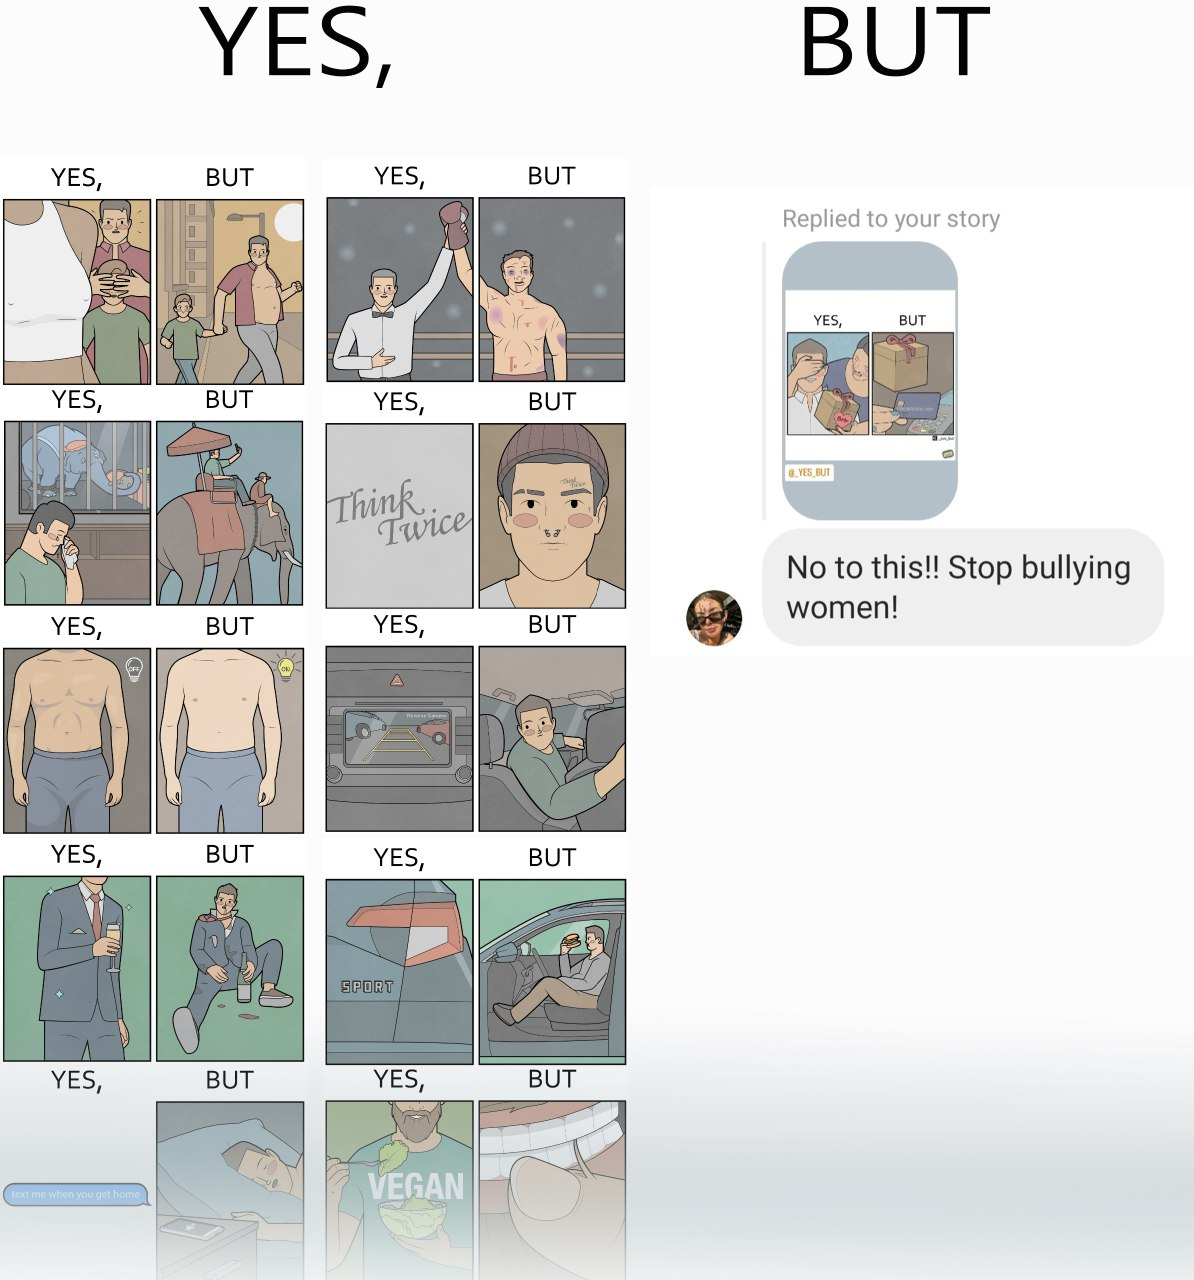What is shown in the left half versus the right half of this image? In the left part of the image: many images, kind of meme, kept in a gallery In the right part of the image: a screenshot of some person replying to other's story raising voice over woman bullying 